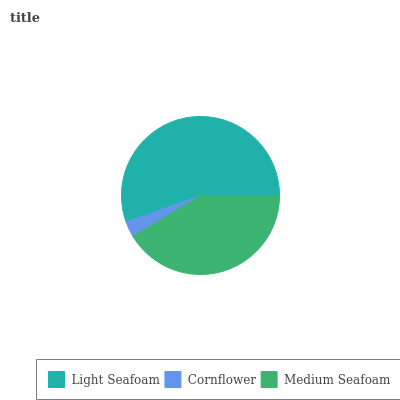Is Cornflower the minimum?
Answer yes or no. Yes. Is Light Seafoam the maximum?
Answer yes or no. Yes. Is Medium Seafoam the minimum?
Answer yes or no. No. Is Medium Seafoam the maximum?
Answer yes or no. No. Is Medium Seafoam greater than Cornflower?
Answer yes or no. Yes. Is Cornflower less than Medium Seafoam?
Answer yes or no. Yes. Is Cornflower greater than Medium Seafoam?
Answer yes or no. No. Is Medium Seafoam less than Cornflower?
Answer yes or no. No. Is Medium Seafoam the high median?
Answer yes or no. Yes. Is Medium Seafoam the low median?
Answer yes or no. Yes. Is Cornflower the high median?
Answer yes or no. No. Is Cornflower the low median?
Answer yes or no. No. 